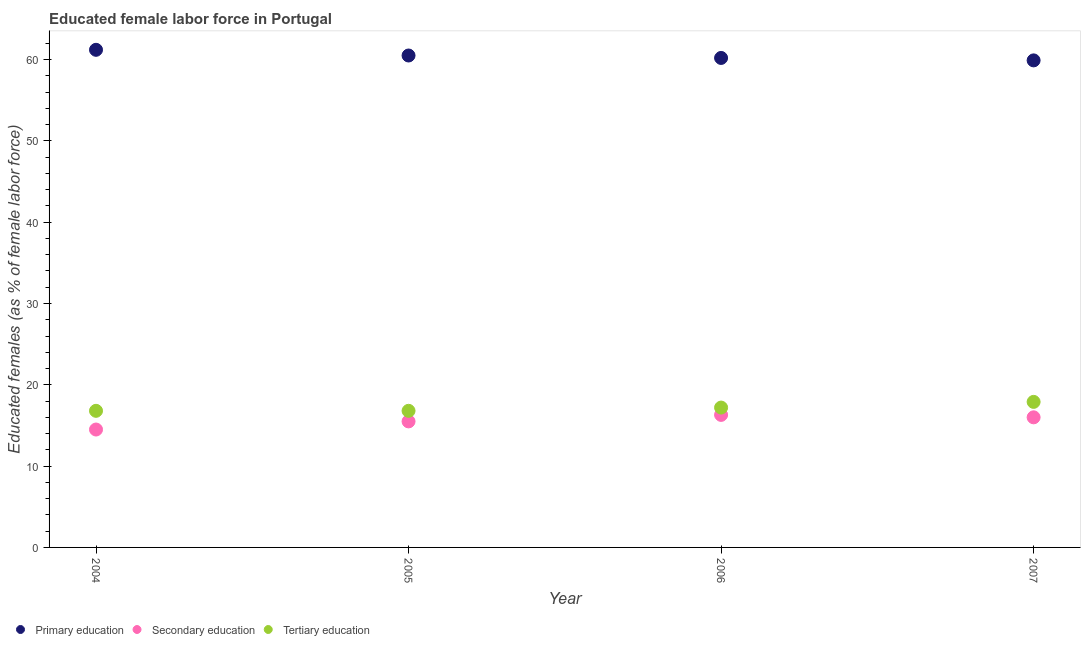What is the percentage of female labor force who received secondary education in 2005?
Provide a short and direct response. 15.5. Across all years, what is the maximum percentage of female labor force who received tertiary education?
Your answer should be very brief. 17.9. In which year was the percentage of female labor force who received secondary education maximum?
Provide a short and direct response. 2006. What is the total percentage of female labor force who received secondary education in the graph?
Keep it short and to the point. 62.3. What is the difference between the percentage of female labor force who received tertiary education in 2005 and that in 2006?
Give a very brief answer. -0.4. What is the difference between the percentage of female labor force who received tertiary education in 2007 and the percentage of female labor force who received primary education in 2005?
Ensure brevity in your answer.  -42.6. What is the average percentage of female labor force who received tertiary education per year?
Your answer should be very brief. 17.17. In the year 2005, what is the difference between the percentage of female labor force who received tertiary education and percentage of female labor force who received primary education?
Keep it short and to the point. -43.7. In how many years, is the percentage of female labor force who received secondary education greater than 40 %?
Provide a short and direct response. 0. What is the ratio of the percentage of female labor force who received primary education in 2004 to that in 2006?
Offer a very short reply. 1.02. Is the percentage of female labor force who received secondary education in 2004 less than that in 2006?
Make the answer very short. Yes. Is the difference between the percentage of female labor force who received tertiary education in 2005 and 2007 greater than the difference between the percentage of female labor force who received secondary education in 2005 and 2007?
Your answer should be very brief. No. What is the difference between the highest and the second highest percentage of female labor force who received primary education?
Keep it short and to the point. 0.7. What is the difference between the highest and the lowest percentage of female labor force who received tertiary education?
Your answer should be compact. 1.1. Is the sum of the percentage of female labor force who received primary education in 2005 and 2007 greater than the maximum percentage of female labor force who received tertiary education across all years?
Make the answer very short. Yes. Is it the case that in every year, the sum of the percentage of female labor force who received primary education and percentage of female labor force who received secondary education is greater than the percentage of female labor force who received tertiary education?
Your answer should be very brief. Yes. Does the percentage of female labor force who received secondary education monotonically increase over the years?
Provide a short and direct response. No. How many years are there in the graph?
Your answer should be very brief. 4. Are the values on the major ticks of Y-axis written in scientific E-notation?
Offer a terse response. No. Does the graph contain any zero values?
Your answer should be compact. No. Does the graph contain grids?
Keep it short and to the point. No. Where does the legend appear in the graph?
Provide a short and direct response. Bottom left. What is the title of the graph?
Offer a terse response. Educated female labor force in Portugal. Does "Agricultural raw materials" appear as one of the legend labels in the graph?
Your answer should be compact. No. What is the label or title of the X-axis?
Ensure brevity in your answer.  Year. What is the label or title of the Y-axis?
Your response must be concise. Educated females (as % of female labor force). What is the Educated females (as % of female labor force) in Primary education in 2004?
Keep it short and to the point. 61.2. What is the Educated females (as % of female labor force) of Tertiary education in 2004?
Your answer should be compact. 16.8. What is the Educated females (as % of female labor force) of Primary education in 2005?
Keep it short and to the point. 60.5. What is the Educated females (as % of female labor force) of Tertiary education in 2005?
Your answer should be compact. 16.8. What is the Educated females (as % of female labor force) of Primary education in 2006?
Provide a short and direct response. 60.2. What is the Educated females (as % of female labor force) of Secondary education in 2006?
Ensure brevity in your answer.  16.3. What is the Educated females (as % of female labor force) in Tertiary education in 2006?
Make the answer very short. 17.2. What is the Educated females (as % of female labor force) of Primary education in 2007?
Ensure brevity in your answer.  59.9. What is the Educated females (as % of female labor force) in Secondary education in 2007?
Provide a short and direct response. 16. What is the Educated females (as % of female labor force) in Tertiary education in 2007?
Offer a terse response. 17.9. Across all years, what is the maximum Educated females (as % of female labor force) of Primary education?
Provide a succinct answer. 61.2. Across all years, what is the maximum Educated females (as % of female labor force) of Secondary education?
Ensure brevity in your answer.  16.3. Across all years, what is the maximum Educated females (as % of female labor force) of Tertiary education?
Your answer should be very brief. 17.9. Across all years, what is the minimum Educated females (as % of female labor force) in Primary education?
Provide a succinct answer. 59.9. Across all years, what is the minimum Educated females (as % of female labor force) in Tertiary education?
Make the answer very short. 16.8. What is the total Educated females (as % of female labor force) in Primary education in the graph?
Make the answer very short. 241.8. What is the total Educated females (as % of female labor force) in Secondary education in the graph?
Make the answer very short. 62.3. What is the total Educated females (as % of female labor force) in Tertiary education in the graph?
Offer a very short reply. 68.7. What is the difference between the Educated females (as % of female labor force) in Primary education in 2004 and that in 2005?
Your response must be concise. 0.7. What is the difference between the Educated females (as % of female labor force) in Tertiary education in 2004 and that in 2005?
Your answer should be compact. 0. What is the difference between the Educated females (as % of female labor force) in Secondary education in 2004 and that in 2006?
Give a very brief answer. -1.8. What is the difference between the Educated females (as % of female labor force) in Primary education in 2004 and that in 2007?
Offer a very short reply. 1.3. What is the difference between the Educated females (as % of female labor force) in Secondary education in 2004 and that in 2007?
Your answer should be compact. -1.5. What is the difference between the Educated females (as % of female labor force) of Primary education in 2005 and that in 2007?
Your answer should be very brief. 0.6. What is the difference between the Educated females (as % of female labor force) of Primary education in 2006 and that in 2007?
Ensure brevity in your answer.  0.3. What is the difference between the Educated females (as % of female labor force) of Secondary education in 2006 and that in 2007?
Keep it short and to the point. 0.3. What is the difference between the Educated females (as % of female labor force) in Tertiary education in 2006 and that in 2007?
Provide a short and direct response. -0.7. What is the difference between the Educated females (as % of female labor force) of Primary education in 2004 and the Educated females (as % of female labor force) of Secondary education in 2005?
Keep it short and to the point. 45.7. What is the difference between the Educated females (as % of female labor force) of Primary education in 2004 and the Educated females (as % of female labor force) of Tertiary education in 2005?
Give a very brief answer. 44.4. What is the difference between the Educated females (as % of female labor force) of Secondary education in 2004 and the Educated females (as % of female labor force) of Tertiary education in 2005?
Keep it short and to the point. -2.3. What is the difference between the Educated females (as % of female labor force) in Primary education in 2004 and the Educated females (as % of female labor force) in Secondary education in 2006?
Keep it short and to the point. 44.9. What is the difference between the Educated females (as % of female labor force) of Secondary education in 2004 and the Educated females (as % of female labor force) of Tertiary education in 2006?
Your answer should be very brief. -2.7. What is the difference between the Educated females (as % of female labor force) of Primary education in 2004 and the Educated females (as % of female labor force) of Secondary education in 2007?
Provide a short and direct response. 45.2. What is the difference between the Educated females (as % of female labor force) in Primary education in 2004 and the Educated females (as % of female labor force) in Tertiary education in 2007?
Provide a succinct answer. 43.3. What is the difference between the Educated females (as % of female labor force) of Secondary education in 2004 and the Educated females (as % of female labor force) of Tertiary education in 2007?
Offer a very short reply. -3.4. What is the difference between the Educated females (as % of female labor force) in Primary education in 2005 and the Educated females (as % of female labor force) in Secondary education in 2006?
Your answer should be compact. 44.2. What is the difference between the Educated females (as % of female labor force) in Primary education in 2005 and the Educated females (as % of female labor force) in Tertiary education in 2006?
Provide a succinct answer. 43.3. What is the difference between the Educated females (as % of female labor force) in Primary education in 2005 and the Educated females (as % of female labor force) in Secondary education in 2007?
Keep it short and to the point. 44.5. What is the difference between the Educated females (as % of female labor force) in Primary education in 2005 and the Educated females (as % of female labor force) in Tertiary education in 2007?
Provide a succinct answer. 42.6. What is the difference between the Educated females (as % of female labor force) of Secondary education in 2005 and the Educated females (as % of female labor force) of Tertiary education in 2007?
Provide a succinct answer. -2.4. What is the difference between the Educated females (as % of female labor force) in Primary education in 2006 and the Educated females (as % of female labor force) in Secondary education in 2007?
Offer a very short reply. 44.2. What is the difference between the Educated females (as % of female labor force) in Primary education in 2006 and the Educated females (as % of female labor force) in Tertiary education in 2007?
Your answer should be very brief. 42.3. What is the average Educated females (as % of female labor force) in Primary education per year?
Provide a short and direct response. 60.45. What is the average Educated females (as % of female labor force) of Secondary education per year?
Give a very brief answer. 15.57. What is the average Educated females (as % of female labor force) in Tertiary education per year?
Make the answer very short. 17.18. In the year 2004, what is the difference between the Educated females (as % of female labor force) in Primary education and Educated females (as % of female labor force) in Secondary education?
Provide a short and direct response. 46.7. In the year 2004, what is the difference between the Educated females (as % of female labor force) in Primary education and Educated females (as % of female labor force) in Tertiary education?
Provide a succinct answer. 44.4. In the year 2004, what is the difference between the Educated females (as % of female labor force) in Secondary education and Educated females (as % of female labor force) in Tertiary education?
Your response must be concise. -2.3. In the year 2005, what is the difference between the Educated females (as % of female labor force) in Primary education and Educated females (as % of female labor force) in Secondary education?
Provide a succinct answer. 45. In the year 2005, what is the difference between the Educated females (as % of female labor force) in Primary education and Educated females (as % of female labor force) in Tertiary education?
Make the answer very short. 43.7. In the year 2006, what is the difference between the Educated females (as % of female labor force) in Primary education and Educated females (as % of female labor force) in Secondary education?
Provide a succinct answer. 43.9. In the year 2007, what is the difference between the Educated females (as % of female labor force) in Primary education and Educated females (as % of female labor force) in Secondary education?
Provide a short and direct response. 43.9. In the year 2007, what is the difference between the Educated females (as % of female labor force) in Primary education and Educated females (as % of female labor force) in Tertiary education?
Ensure brevity in your answer.  42. What is the ratio of the Educated females (as % of female labor force) of Primary education in 2004 to that in 2005?
Give a very brief answer. 1.01. What is the ratio of the Educated females (as % of female labor force) in Secondary education in 2004 to that in 2005?
Provide a short and direct response. 0.94. What is the ratio of the Educated females (as % of female labor force) of Primary education in 2004 to that in 2006?
Offer a terse response. 1.02. What is the ratio of the Educated females (as % of female labor force) of Secondary education in 2004 to that in 2006?
Your answer should be very brief. 0.89. What is the ratio of the Educated females (as % of female labor force) of Tertiary education in 2004 to that in 2006?
Your response must be concise. 0.98. What is the ratio of the Educated females (as % of female labor force) of Primary education in 2004 to that in 2007?
Ensure brevity in your answer.  1.02. What is the ratio of the Educated females (as % of female labor force) of Secondary education in 2004 to that in 2007?
Ensure brevity in your answer.  0.91. What is the ratio of the Educated females (as % of female labor force) in Tertiary education in 2004 to that in 2007?
Your answer should be very brief. 0.94. What is the ratio of the Educated females (as % of female labor force) in Primary education in 2005 to that in 2006?
Keep it short and to the point. 1. What is the ratio of the Educated females (as % of female labor force) in Secondary education in 2005 to that in 2006?
Make the answer very short. 0.95. What is the ratio of the Educated females (as % of female labor force) in Tertiary education in 2005 to that in 2006?
Give a very brief answer. 0.98. What is the ratio of the Educated females (as % of female labor force) of Secondary education in 2005 to that in 2007?
Make the answer very short. 0.97. What is the ratio of the Educated females (as % of female labor force) in Tertiary education in 2005 to that in 2007?
Offer a very short reply. 0.94. What is the ratio of the Educated females (as % of female labor force) of Primary education in 2006 to that in 2007?
Keep it short and to the point. 1. What is the ratio of the Educated females (as % of female labor force) of Secondary education in 2006 to that in 2007?
Make the answer very short. 1.02. What is the ratio of the Educated females (as % of female labor force) in Tertiary education in 2006 to that in 2007?
Your response must be concise. 0.96. What is the difference between the highest and the second highest Educated females (as % of female labor force) of Primary education?
Provide a succinct answer. 0.7. What is the difference between the highest and the second highest Educated females (as % of female labor force) of Secondary education?
Your answer should be compact. 0.3. What is the difference between the highest and the second highest Educated females (as % of female labor force) in Tertiary education?
Keep it short and to the point. 0.7. What is the difference between the highest and the lowest Educated females (as % of female labor force) of Primary education?
Make the answer very short. 1.3. What is the difference between the highest and the lowest Educated females (as % of female labor force) in Tertiary education?
Provide a succinct answer. 1.1. 